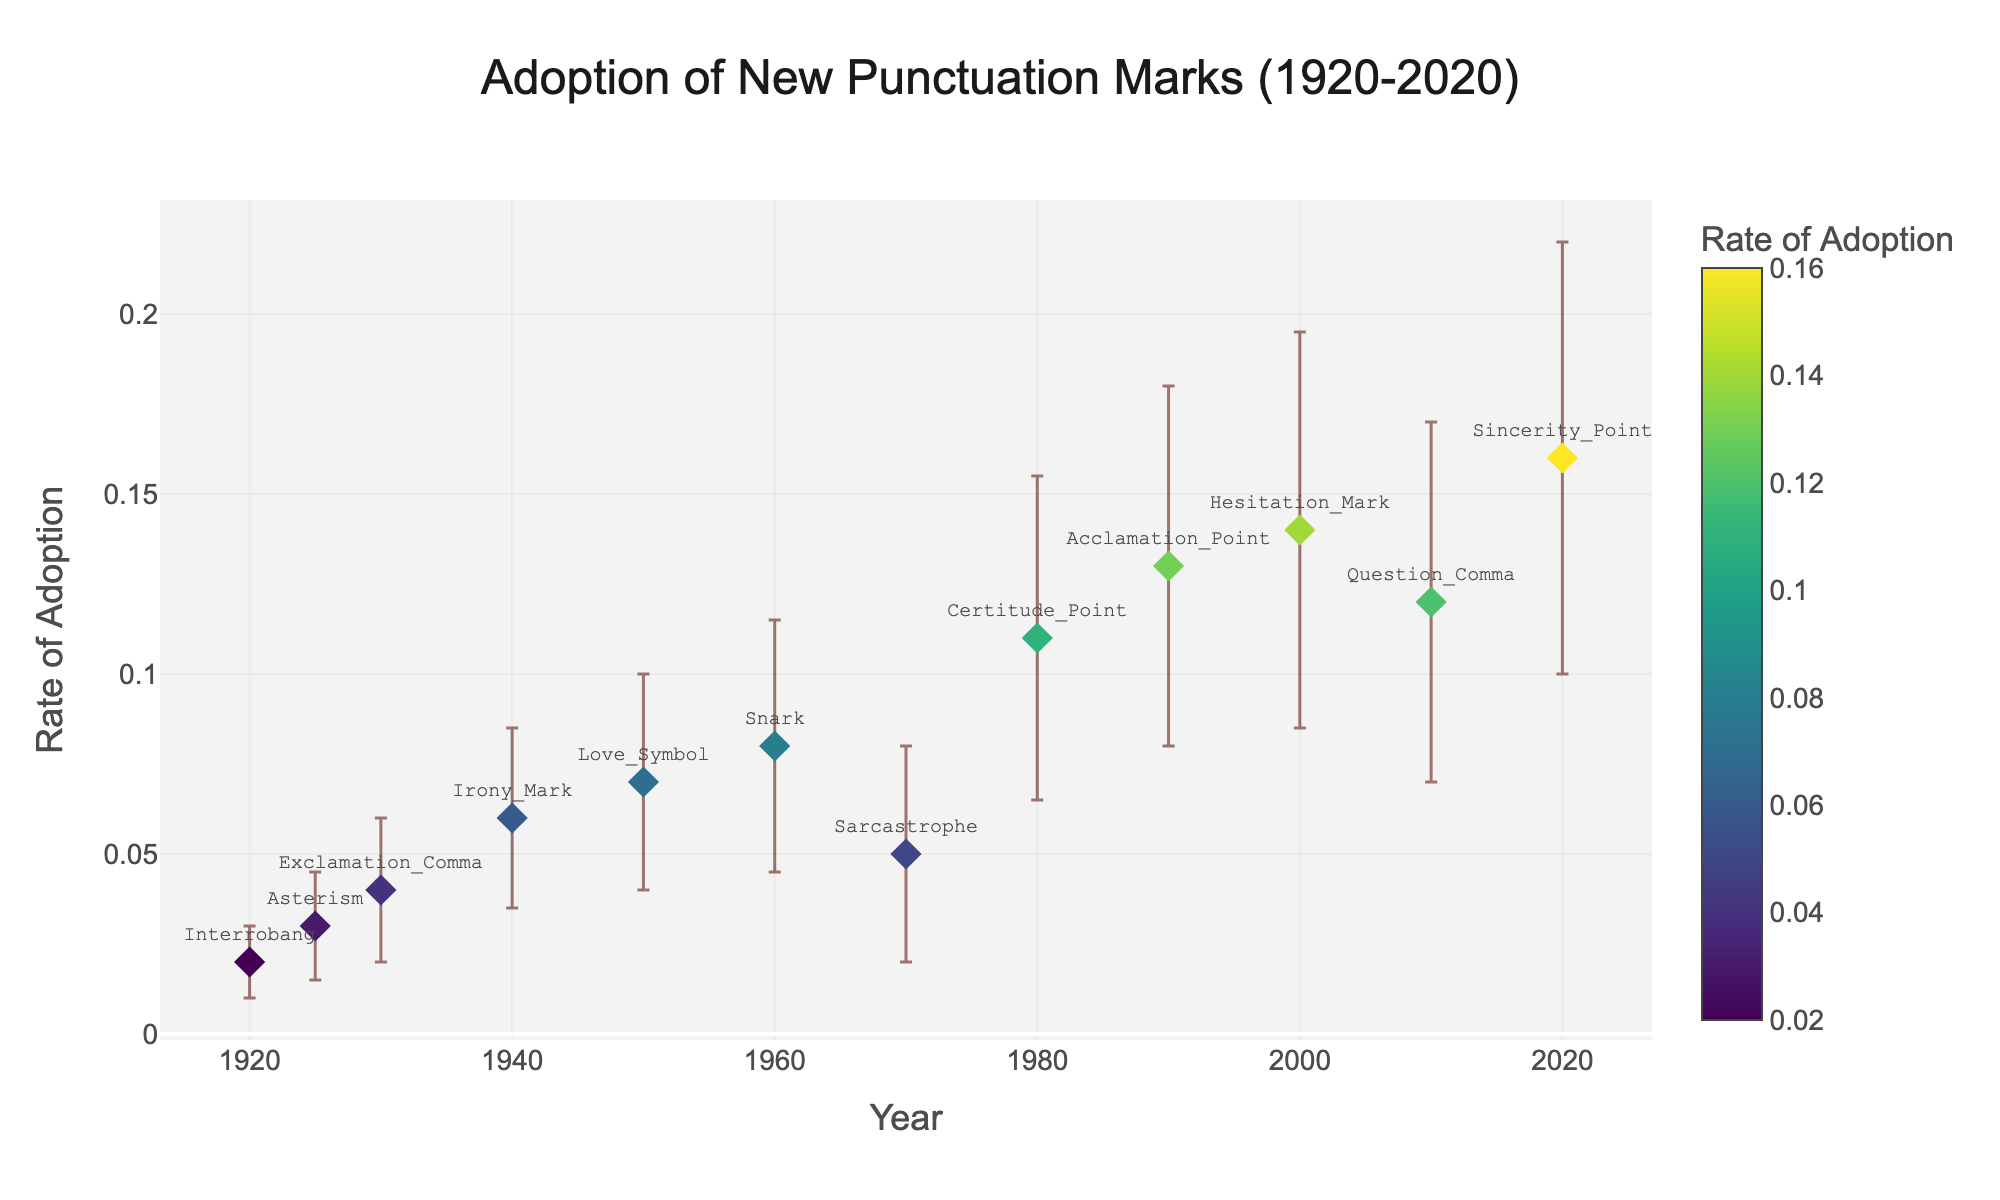What's the title of the scatter plot? The title is found at the top center of the plot and it is designed to summarize the content depicted in the graph.
Answer: Adoption of New Punctuation Marks (1920-2020) What's the range of the Y-axis? Observing the labels on the Y-axis from the lowest to the highest value provides the range information.
Answer: 0 to 0.20 Which punctuation mark had the highest rate of adoption in 2010? Locate the year 2010 on the X-axis and identify the corresponding punctuation mark labeled in the scatter plot.
Answer: Question_Comma What is the approximate rate of adoption for the Asterism in 1925? Find the year 1925 along the X-axis and look at the Y-axis value for the Asterism data point.
Answer: 0.03 Which year had the largest error bar, and what is the punctuation mark and its rate of adoption? Identify the data point with the biggest vertical error bar by visual comparison and note its position on the X and Y axes.
Answer: 2020, Sincerity_Point, 0.16 How does the rate of adoption for the Love_Symbol in 1950 compare to that of the Sarcastrophe in 1970? Compare the Y-axis values of the data points for Love_Symbol in 1950 and Sarcastrophe in 1970.
Answer: Love_Symbol is higher Which decade saw the introduction of the punctuation mark with the highest rate of adoption? Find the highest point on the scatter plot and observe its position on the X-axis, which indicates the decade.
Answer: 2020s Among Interrobang, Sarcastrophe, and Acclamation_Point, which has the lowest rate of adoption, and what is it? Compare the Y-axis values of these data points and identify the lowest one.
Answer: Interrobang, 0.02 